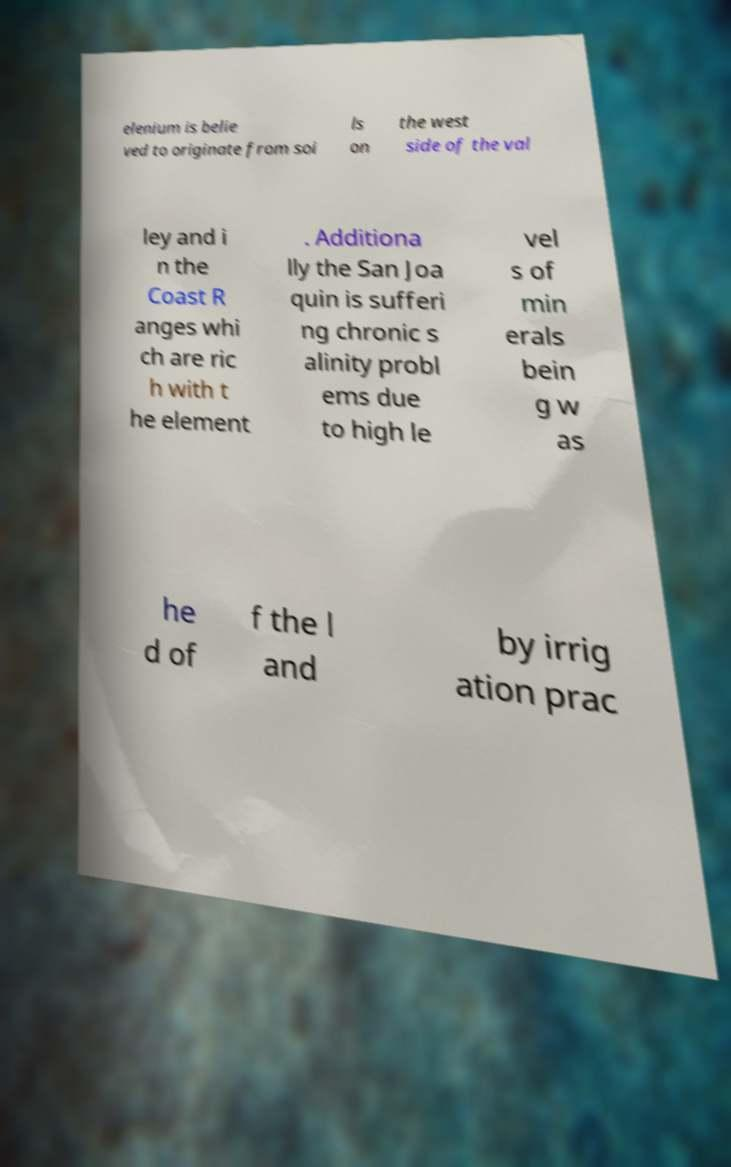Can you read and provide the text displayed in the image?This photo seems to have some interesting text. Can you extract and type it out for me? elenium is belie ved to originate from soi ls on the west side of the val ley and i n the Coast R anges whi ch are ric h with t he element . Additiona lly the San Joa quin is sufferi ng chronic s alinity probl ems due to high le vel s of min erals bein g w as he d of f the l and by irrig ation prac 